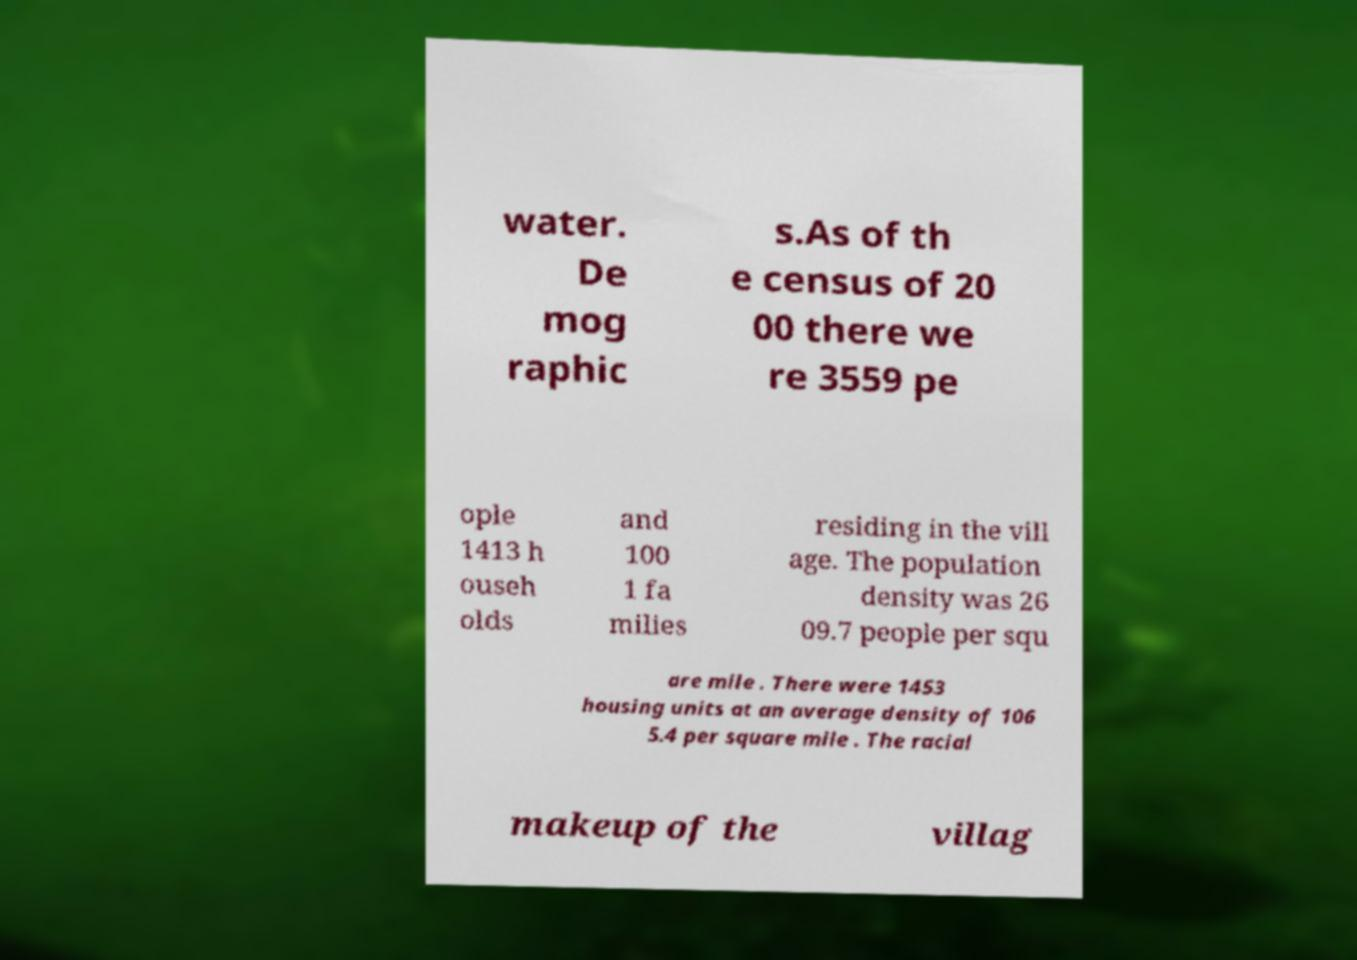Can you read and provide the text displayed in the image?This photo seems to have some interesting text. Can you extract and type it out for me? water. De mog raphic s.As of th e census of 20 00 there we re 3559 pe ople 1413 h ouseh olds and 100 1 fa milies residing in the vill age. The population density was 26 09.7 people per squ are mile . There were 1453 housing units at an average density of 106 5.4 per square mile . The racial makeup of the villag 